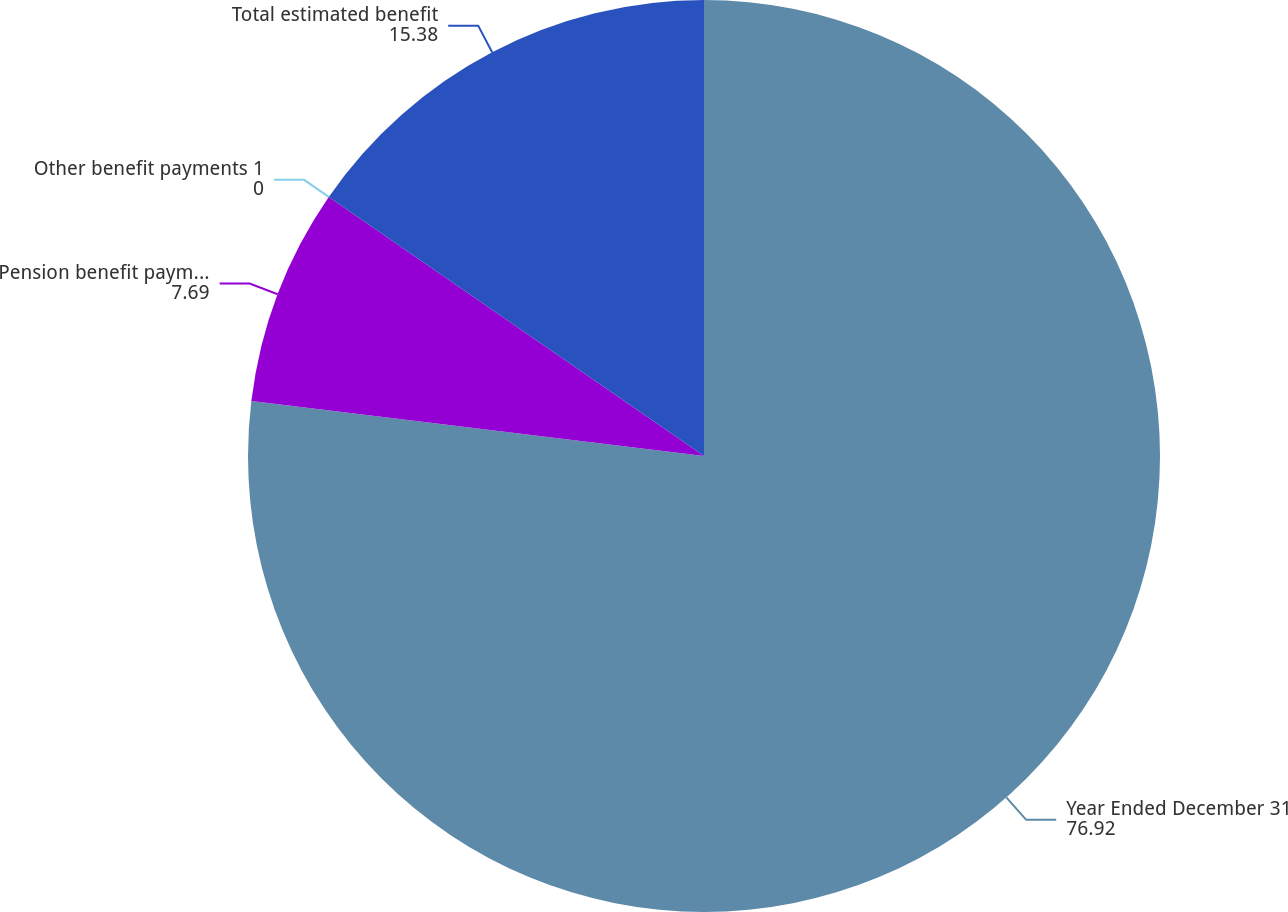<chart> <loc_0><loc_0><loc_500><loc_500><pie_chart><fcel>Year Ended December 31<fcel>Pension benefit payments<fcel>Other benefit payments 1<fcel>Total estimated benefit<nl><fcel>76.92%<fcel>7.69%<fcel>0.0%<fcel>15.38%<nl></chart> 